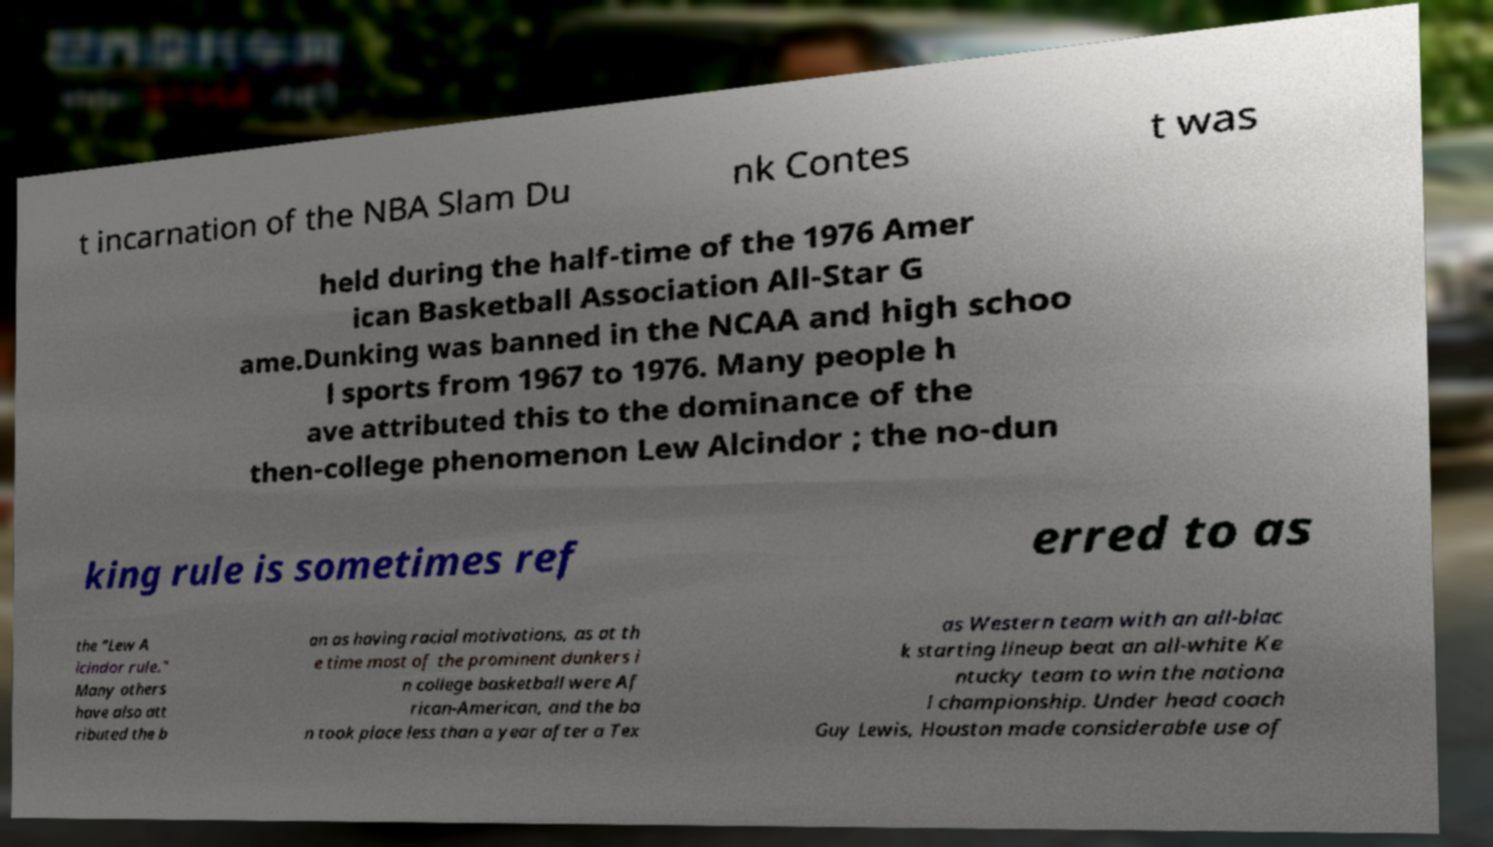Can you accurately transcribe the text from the provided image for me? t incarnation of the NBA Slam Du nk Contes t was held during the half-time of the 1976 Amer ican Basketball Association All-Star G ame.Dunking was banned in the NCAA and high schoo l sports from 1967 to 1976. Many people h ave attributed this to the dominance of the then-college phenomenon Lew Alcindor ; the no-dun king rule is sometimes ref erred to as the "Lew A lcindor rule." Many others have also att ributed the b an as having racial motivations, as at th e time most of the prominent dunkers i n college basketball were Af rican-American, and the ba n took place less than a year after a Tex as Western team with an all-blac k starting lineup beat an all-white Ke ntucky team to win the nationa l championship. Under head coach Guy Lewis, Houston made considerable use of 